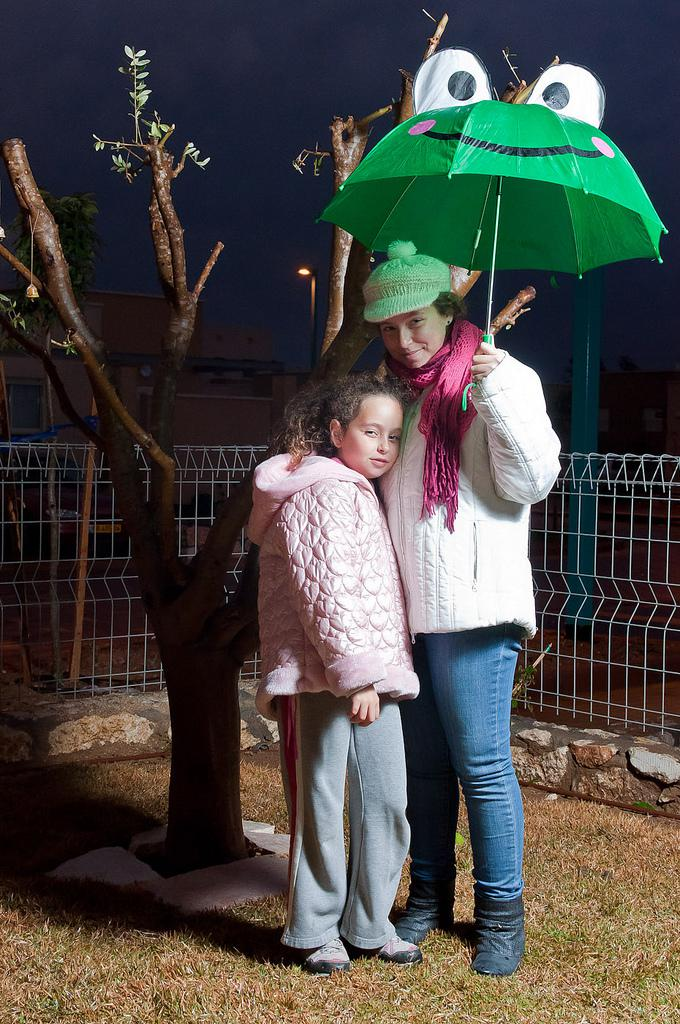Question: how many people are in the picture?
Choices:
A. Three people.
B. Four people.
C. Two people.
D. Five people.
Answer with the letter. Answer: C Question: who is wearing a pink jacket?
Choices:
A. A boy.
B. A woman.
C. A dog.
D. A girl.
Answer with the letter. Answer: D Question: why are they wearing jackets?
Choices:
A. They are fasionable.
B. They are social symbol.
C. Because they are cold.
D. It is raining.
Answer with the letter. Answer: C Question: where are the pink circles?
Choices:
A. On the shopping bag.
B. In the store's logo.
C. At the end of the frog's smile.
D. On the little girl's shirt.
Answer with the letter. Answer: C Question: what are they standing under?
Choices:
A. A frog umbrella.
B. A ledge.
C. A balcony.
D. The pouring rain.
Answer with the letter. Answer: A Question: who is wearing a pink coat?
Choices:
A. The little girl.
B. The old lady.
C. The teenage girl.
D. The feminine gentleman.
Answer with the letter. Answer: A Question: when was the picture taken?
Choices:
A. Dusk.
B. Noon.
C. Nighttime.
D. Early morning.
Answer with the letter. Answer: C Question: who is wearing a cap?
Choices:
A. Young girl.
B. Little league player.
C. Elderly man.
D. Older lady.
Answer with the letter. Answer: D Question: what is behind the people?
Choices:
A. A tree.
B. Bushes.
C. Cars.
D. Stores.
Answer with the letter. Answer: A Question: what are the two people doing?
Choices:
A. Kissing.
B. Holding hands.
C. Walking.
D. The two people are standing.
Answer with the letter. Answer: D Question: who is wearing black boots?
Choices:
A. The jockey.
B. The two teenagers.
C. The man on the right.
D. The woman.
Answer with the letter. Answer: D Question: what color is the people's hair?
Choices:
A. Black.
B. Blonde.
C. Red.
D. Brown.
Answer with the letter. Answer: D Question: who's wearing a hat?
Choices:
A. The batter.
B. The two kids playing in the snow.
C. The woman.
D. The boy on the left.
Answer with the letter. Answer: C 